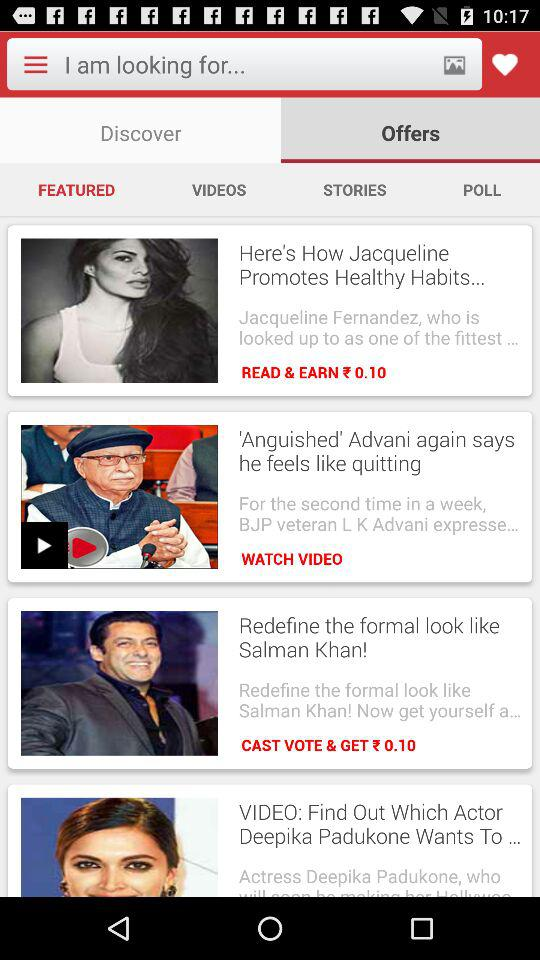How much will be earned by reading? Reading will earn ₹0.10. 